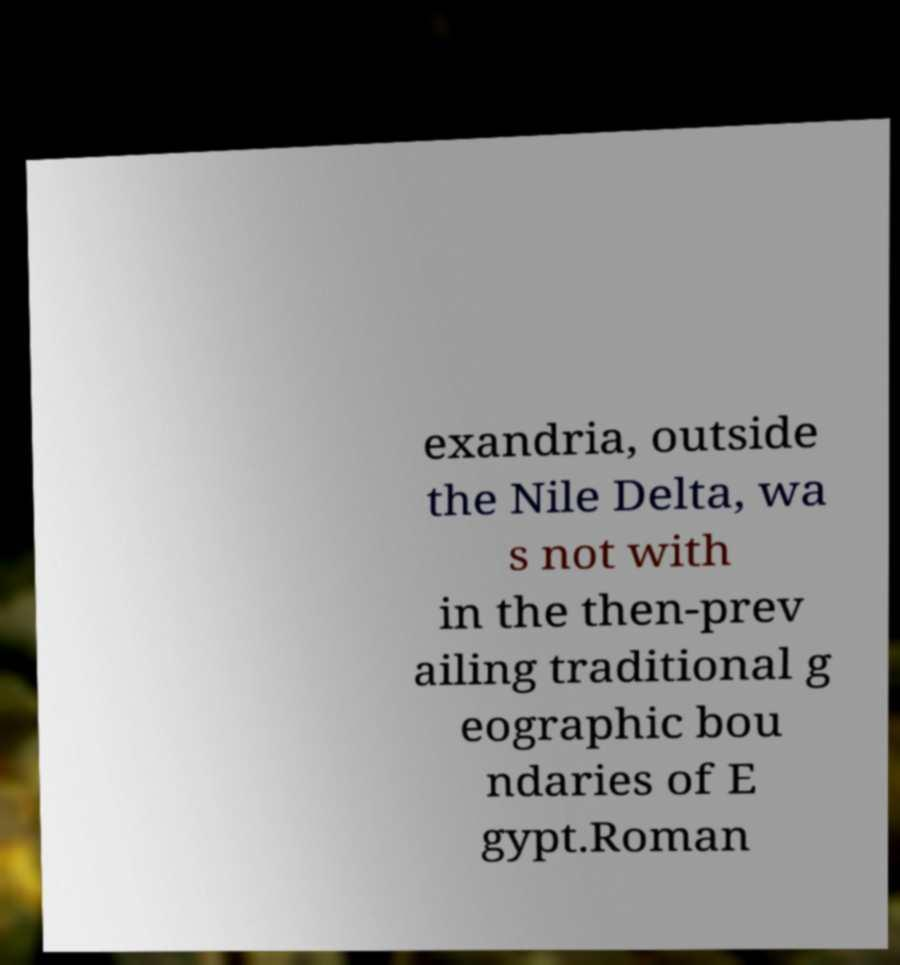There's text embedded in this image that I need extracted. Can you transcribe it verbatim? exandria, outside the Nile Delta, wa s not with in the then-prev ailing traditional g eographic bou ndaries of E gypt.Roman 